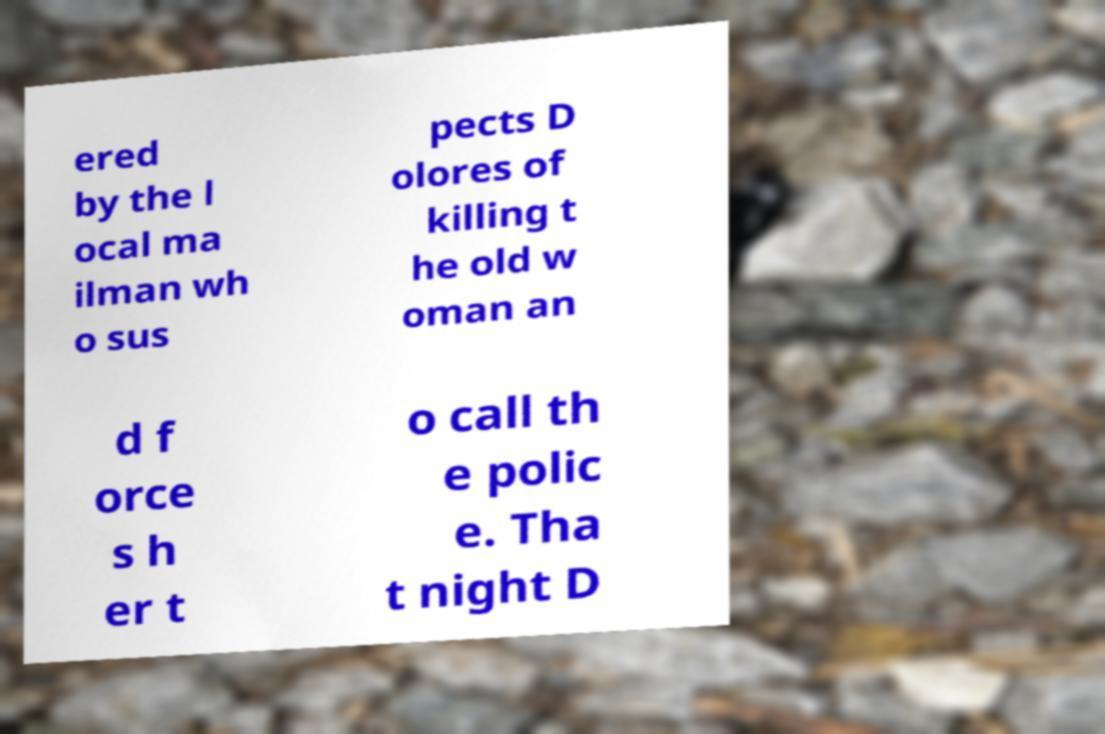There's text embedded in this image that I need extracted. Can you transcribe it verbatim? ered by the l ocal ma ilman wh o sus pects D olores of killing t he old w oman an d f orce s h er t o call th e polic e. Tha t night D 